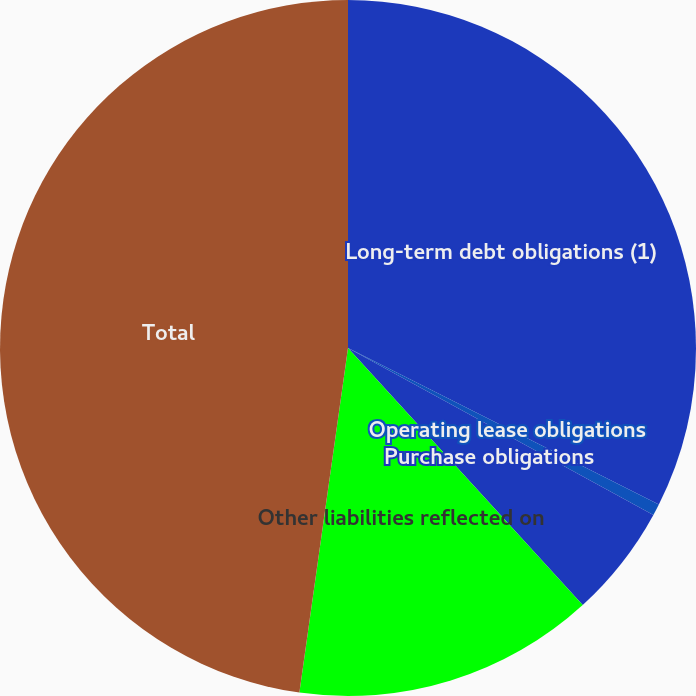Convert chart to OTSL. <chart><loc_0><loc_0><loc_500><loc_500><pie_chart><fcel>Long-term debt obligations (1)<fcel>Operating lease obligations<fcel>Purchase obligations<fcel>Other liabilities reflected on<fcel>Total<nl><fcel>32.42%<fcel>0.54%<fcel>5.26%<fcel>14.01%<fcel>47.77%<nl></chart> 